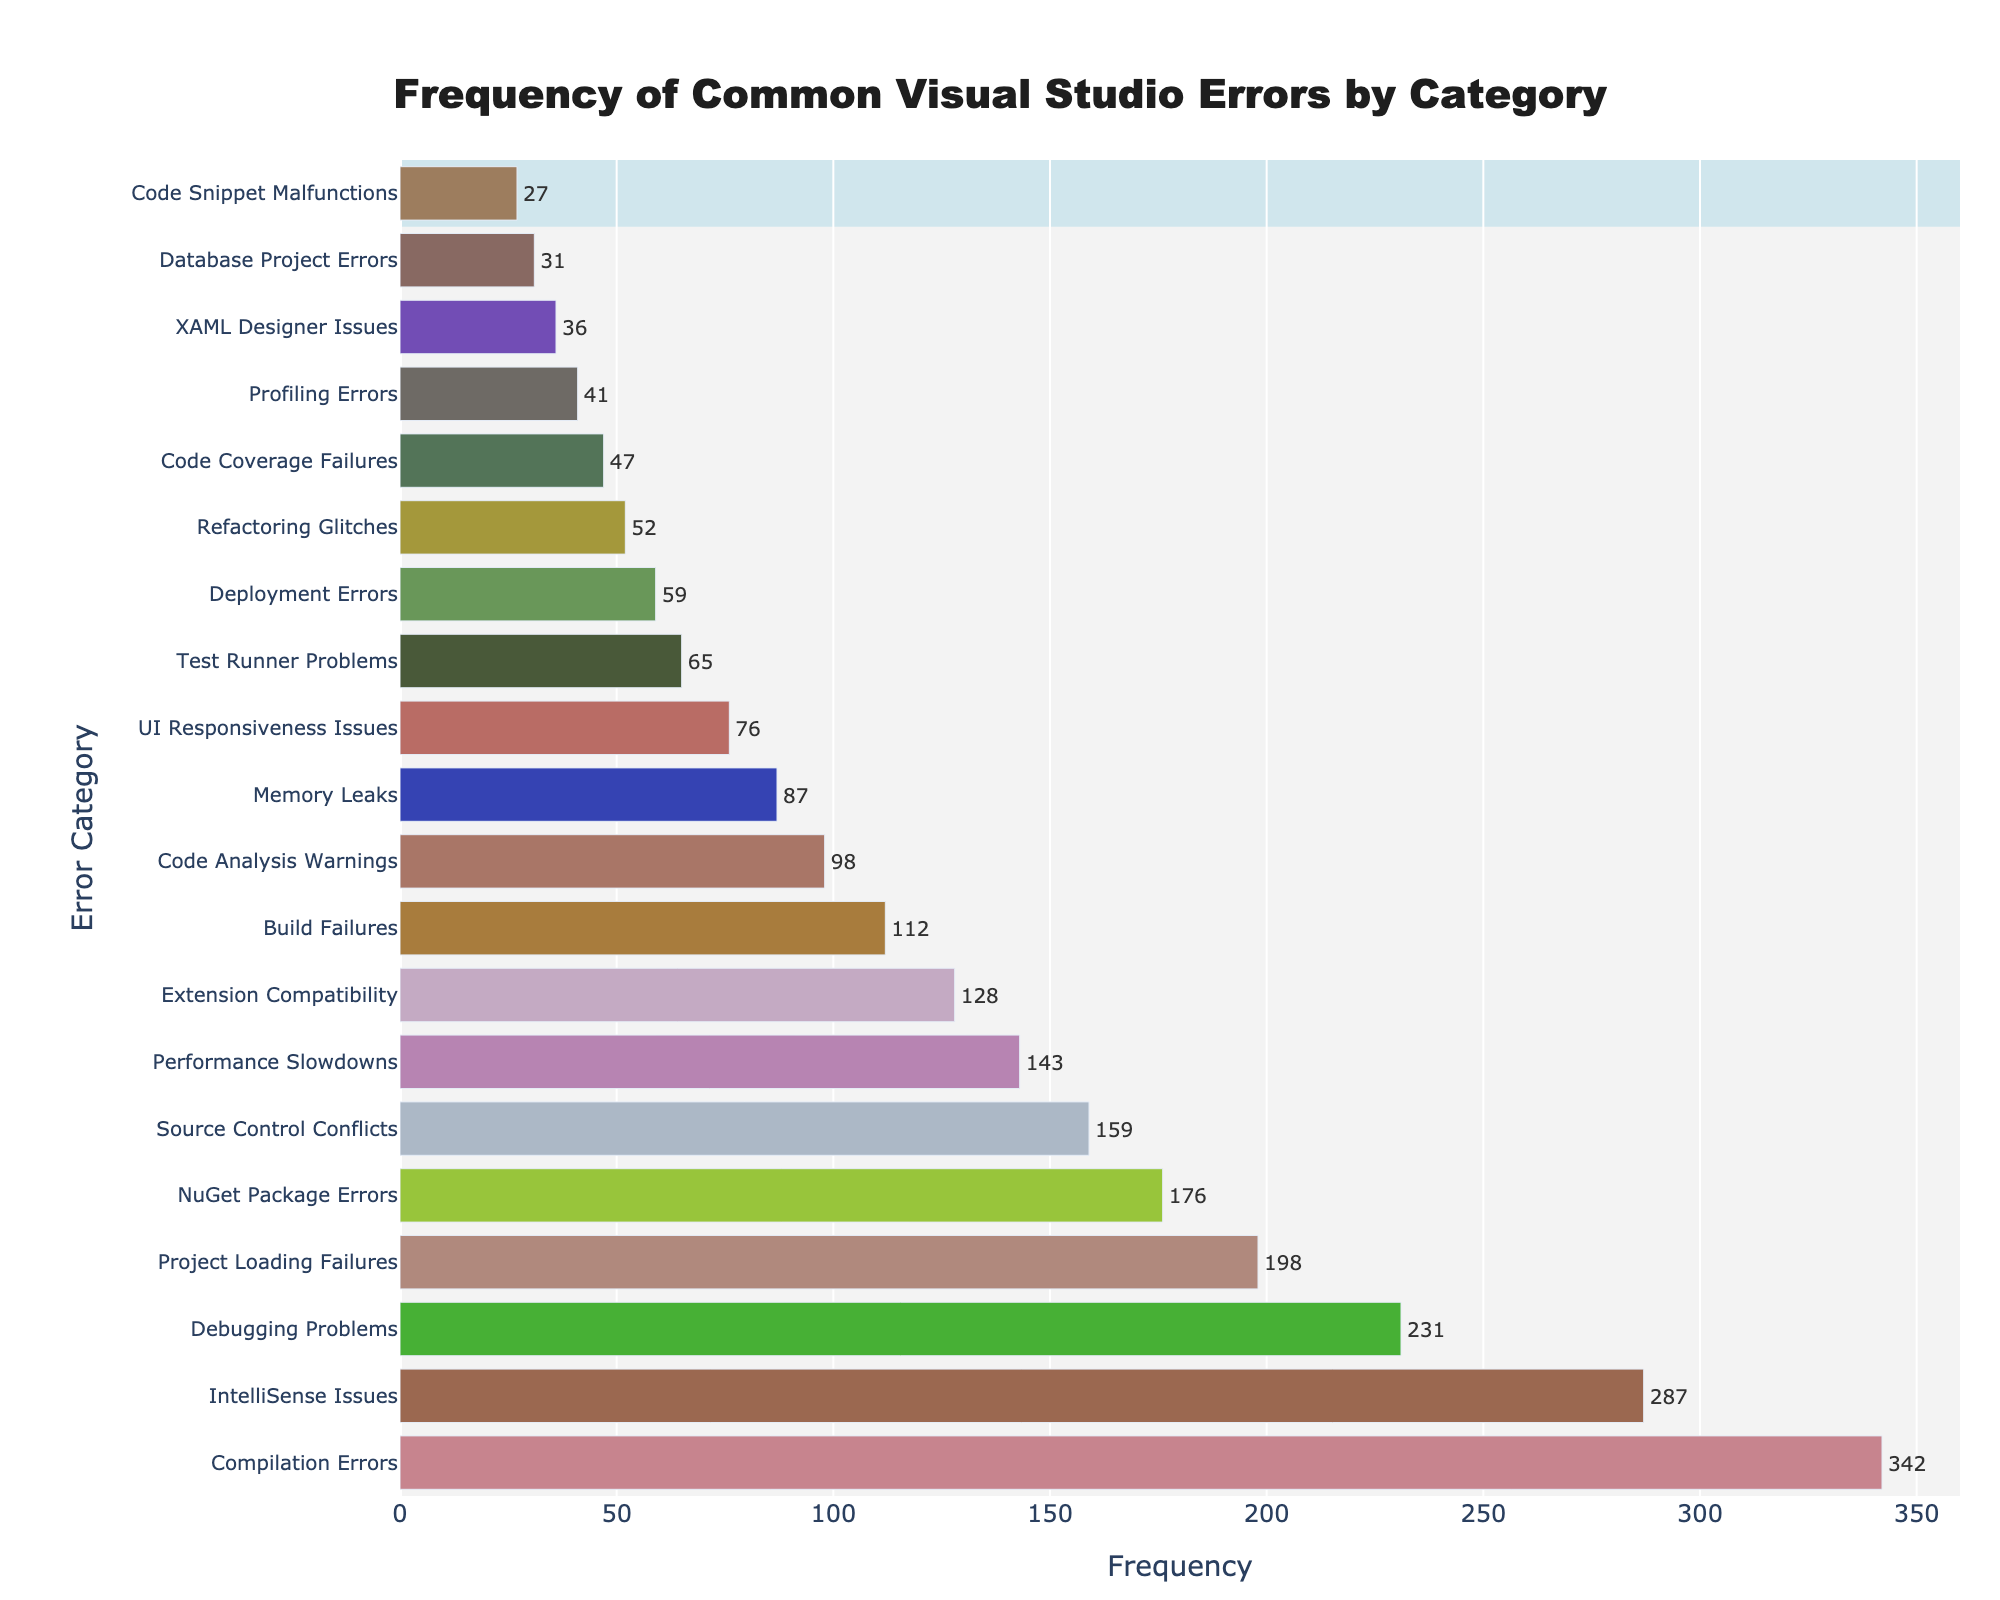What's the most common category of Visual Studio errors? To determine the most common category, look at the bar with the highest frequency value on the chart. The "Compilation Errors" bar is the highest.
Answer: Compilation Errors What's the total frequency of Debugging Problems and Project Loading Failures? Debugging Problems have a frequency of 231 and Project Loading Failures have a frequency of 198. Adding these values together: 231 + 198 = 429
Answer: 429 Which visual attribute indicates the Frequencies on the chart? The Frequencies are indicated by the lengths of the horizontal bars. Longer bars correspond to higher frequencies.
Answer: Length of the bars Which category has a lower frequency: Extension Compatibility or UI Responsiveness Issues? Compare the frequencies of both categories from the chart. Extension Compatibility has a frequency of 128, while UI Responsiveness Issues have a frequency of 76. Hence, UI Responsiveness Issues have a lower frequency.
Answer: UI Responsiveness Issues What is the frequency difference between NuGet Package Errors and Memory Leaks? NuGet Package Errors have a frequency of 176, and Memory Leaks have a frequency of 87. The difference is calculated as 176 - 87 = 89
Answer: 89 Is the frequency of IntelliSense Issues greater than the frequency of Source Control Conflicts? IntelliSense Issues have a frequency of 287, while Source Control Conflicts have a frequency of 159. Since 287 > 159, IntelliSense Issues have a greater frequency.
Answer: Yes What's the average frequency of Code Analysis Warnings, Test Runner Problems, and Deployment Errors? Code Analysis Warnings have a frequency of 98, Test Runner Problems have a frequency of 65, and Deployment Errors have a frequency of 59. The average is calculated as (98 + 65 + 59) / 3 = 74
Answer: 74 Which category occupies the mid-point frequency between Build Failures and Profiling Errors? The frequencies are: Build Failures = 112, Profiling Errors = 41. The midpoint frequency is calculated as (112 + 41) / 2 = 76.5. Looking at the chart, UI Responsiveness Issues have a frequency of 76, which is closest to 76.5.
Answer: UI Responsiveness Issues How many categories have frequencies higher than 200? From the chart, the following categories have frequencies higher than 200: Compilation Errors (342), IntelliSense Issues (287), and Debugging Problems (231). That's 3 categories.
Answer: 3 